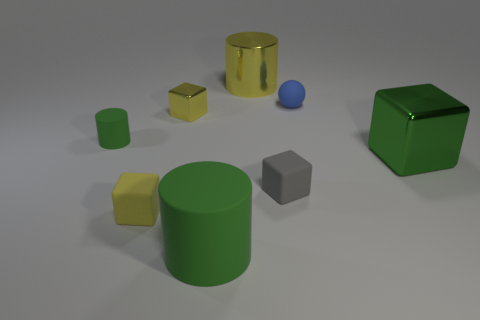The other matte thing that is the same shape as the big green matte thing is what color?
Provide a short and direct response. Green. How many tiny green things are the same shape as the large yellow shiny object?
Ensure brevity in your answer.  1. There is a big cylinder that is the same color as the tiny cylinder; what material is it?
Make the answer very short. Rubber. What number of gray rubber things are there?
Offer a terse response. 1. Is there another cyan sphere made of the same material as the tiny ball?
Provide a short and direct response. No. There is a metal cube that is the same color as the big metal cylinder; what is its size?
Give a very brief answer. Small. There is a metal block right of the tiny rubber ball; is its size the same as the cylinder behind the small rubber sphere?
Offer a terse response. Yes. There is a metallic thing that is behind the small yellow shiny block; how big is it?
Keep it short and to the point. Large. Are there any small cylinders of the same color as the large cube?
Ensure brevity in your answer.  Yes. Are there any big things left of the large metal thing that is to the left of the small rubber sphere?
Provide a succinct answer. Yes. 